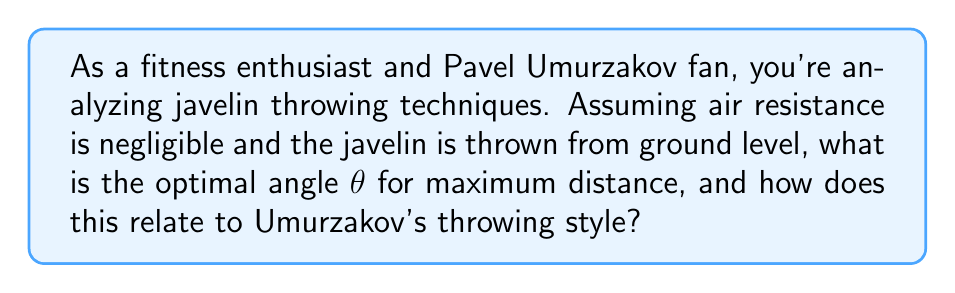Can you answer this question? Let's approach this step-by-step:

1) In an ideal scenario without air resistance, the trajectory of the javelin follows a parabolic path described by the equations of motion:

   $$x = v_0 \cos(\theta) t$$
   $$y = v_0 \sin(\theta) t - \frac{1}{2}gt^2$$

   Where $v_0$ is the initial velocity, $\theta$ is the launch angle, $t$ is time, and $g$ is the acceleration due to gravity.

2) The range (horizontal distance) $R$ is given by:

   $$R = \frac{v_0^2}{g} \sin(2\theta)$$

3) To find the maximum range, we need to maximize $\sin(2\theta)$. The maximum value of sine is 1, which occurs when its argument is 90°.

4) Therefore:

   $$2\theta = 90°$$
   $$\theta = 45°$$

5) This result shows that the optimal angle for maximum distance in javelin throwing, neglecting air resistance, is 45°.

6) However, in real-world conditions, air resistance plays a significant role. The actual optimal angle is typically lower, around 35-38°.

7) Pavel Umurzakov, known for his powerful throws, likely uses an angle close to this real-world optimum. His technique would balance the theoretical ideal with practical considerations of air resistance and the aerodynamics of the javelin.
Answer: 45° (ideal); ~35-38° (real-world) 